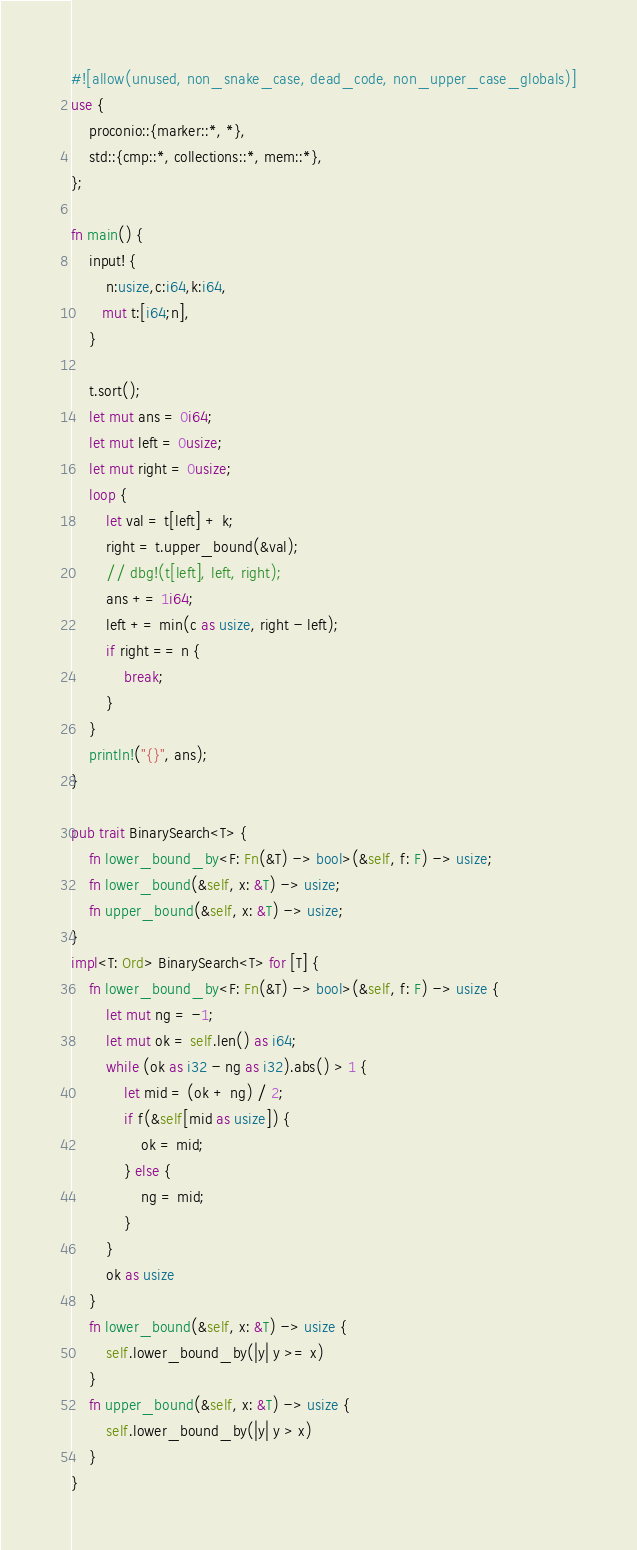Convert code to text. <code><loc_0><loc_0><loc_500><loc_500><_Rust_>#![allow(unused, non_snake_case, dead_code, non_upper_case_globals)]
use {
    proconio::{marker::*, *},
    std::{cmp::*, collections::*, mem::*},
};

fn main() {
    input! {
        n:usize,c:i64,k:i64,
       mut t:[i64;n],
    }

    t.sort();
    let mut ans = 0i64;
    let mut left = 0usize;
    let mut right = 0usize;
    loop {
        let val = t[left] + k;
        right = t.upper_bound(&val);
        // dbg!(t[left], left, right);
        ans += 1i64;
        left += min(c as usize, right - left);
        if right == n {
            break;
        }
    }
    println!("{}", ans);
}

pub trait BinarySearch<T> {
    fn lower_bound_by<F: Fn(&T) -> bool>(&self, f: F) -> usize;
    fn lower_bound(&self, x: &T) -> usize;
    fn upper_bound(&self, x: &T) -> usize;
}
impl<T: Ord> BinarySearch<T> for [T] {
    fn lower_bound_by<F: Fn(&T) -> bool>(&self, f: F) -> usize {
        let mut ng = -1;
        let mut ok = self.len() as i64;
        while (ok as i32 - ng as i32).abs() > 1 {
            let mid = (ok + ng) / 2;
            if f(&self[mid as usize]) {
                ok = mid;
            } else {
                ng = mid;
            }
        }
        ok as usize
    }
    fn lower_bound(&self, x: &T) -> usize {
        self.lower_bound_by(|y| y >= x)
    }
    fn upper_bound(&self, x: &T) -> usize {
        self.lower_bound_by(|y| y > x)
    }
}
</code> 